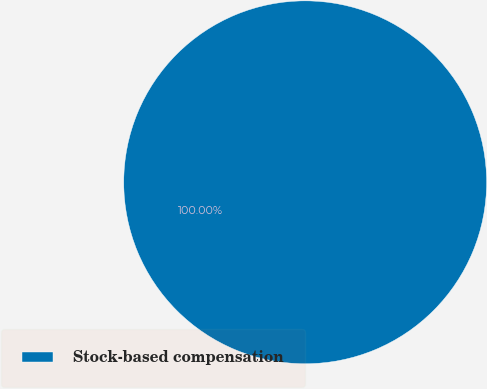Convert chart to OTSL. <chart><loc_0><loc_0><loc_500><loc_500><pie_chart><fcel>Stock-based compensation<nl><fcel>100.0%<nl></chart> 